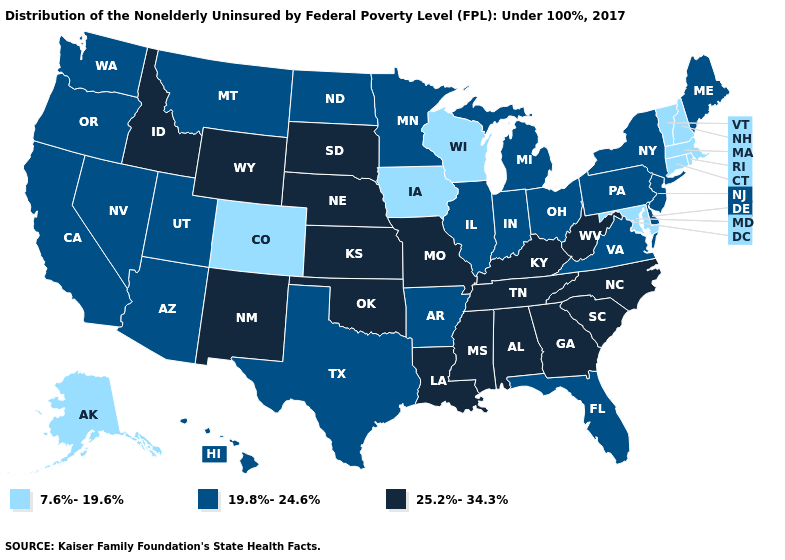Does Vermont have the lowest value in the Northeast?
Short answer required. Yes. Does Pennsylvania have a lower value than South Carolina?
Answer briefly. Yes. Does California have a lower value than Georgia?
Answer briefly. Yes. Does the first symbol in the legend represent the smallest category?
Quick response, please. Yes. How many symbols are there in the legend?
Quick response, please. 3. What is the lowest value in the USA?
Give a very brief answer. 7.6%-19.6%. Name the states that have a value in the range 7.6%-19.6%?
Be succinct. Alaska, Colorado, Connecticut, Iowa, Maryland, Massachusetts, New Hampshire, Rhode Island, Vermont, Wisconsin. Which states have the lowest value in the Northeast?
Short answer required. Connecticut, Massachusetts, New Hampshire, Rhode Island, Vermont. What is the value of Colorado?
Give a very brief answer. 7.6%-19.6%. Does Nebraska have the same value as Oklahoma?
Give a very brief answer. Yes. Does Iowa have the highest value in the USA?
Be succinct. No. What is the value of Idaho?
Answer briefly. 25.2%-34.3%. Does the map have missing data?
Give a very brief answer. No. Name the states that have a value in the range 25.2%-34.3%?
Answer briefly. Alabama, Georgia, Idaho, Kansas, Kentucky, Louisiana, Mississippi, Missouri, Nebraska, New Mexico, North Carolina, Oklahoma, South Carolina, South Dakota, Tennessee, West Virginia, Wyoming. Name the states that have a value in the range 7.6%-19.6%?
Give a very brief answer. Alaska, Colorado, Connecticut, Iowa, Maryland, Massachusetts, New Hampshire, Rhode Island, Vermont, Wisconsin. 